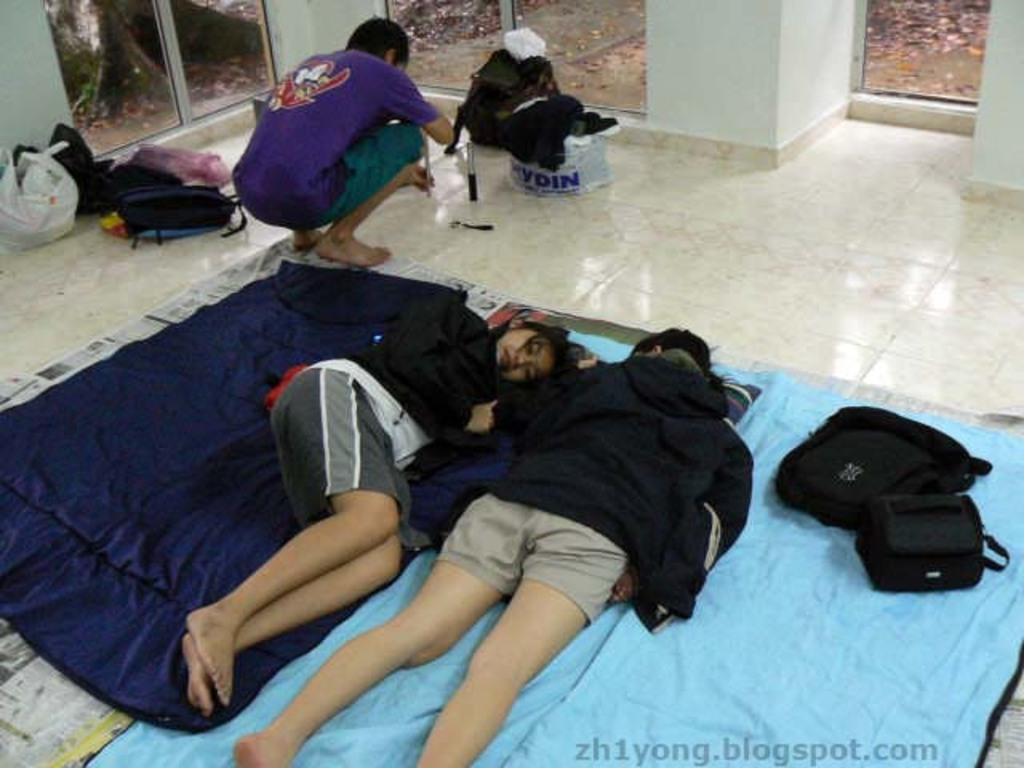<image>
Share a concise interpretation of the image provided. Children are sleeping on a marble floor and there is a bag of clothes that says Kydin next to them. 